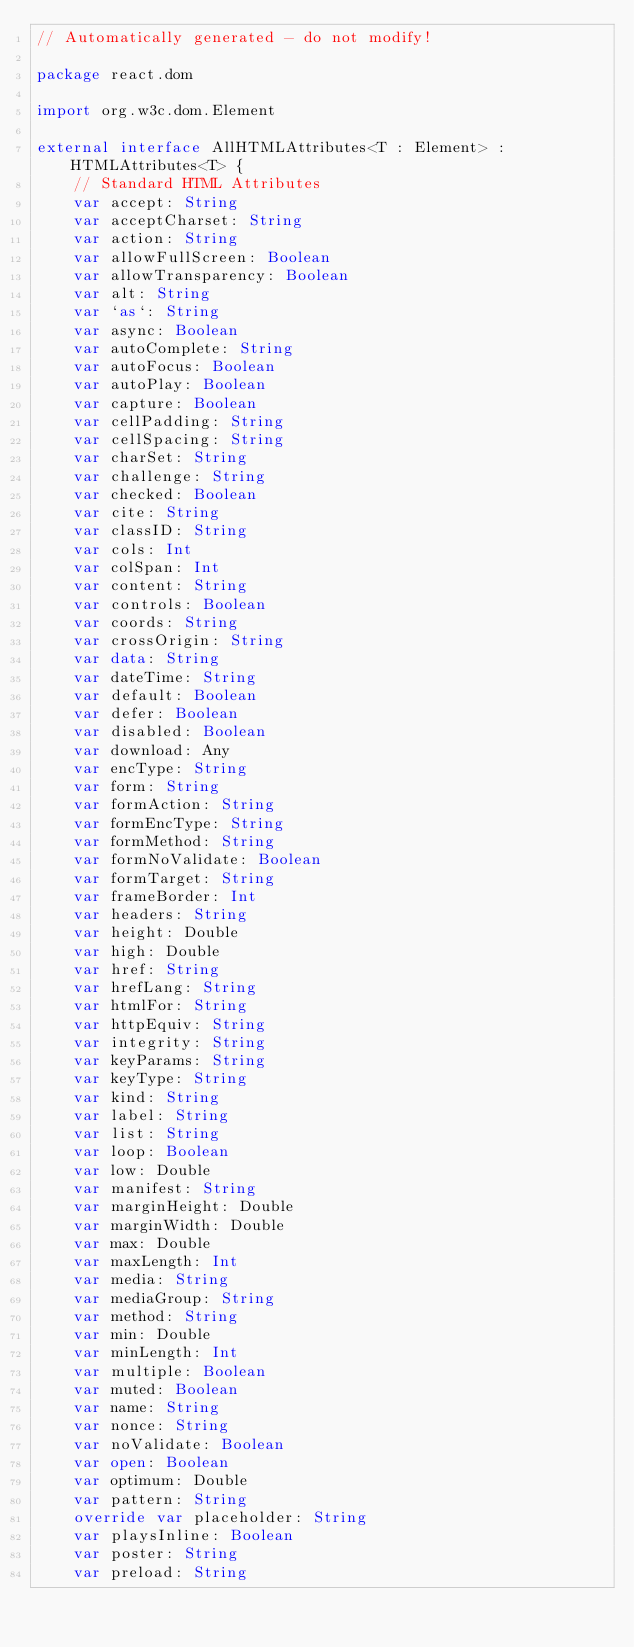Convert code to text. <code><loc_0><loc_0><loc_500><loc_500><_Kotlin_>// Automatically generated - do not modify!

package react.dom

import org.w3c.dom.Element

external interface AllHTMLAttributes<T : Element> : HTMLAttributes<T> {
    // Standard HTML Attributes
    var accept: String
    var acceptCharset: String
    var action: String
    var allowFullScreen: Boolean
    var allowTransparency: Boolean
    var alt: String
    var `as`: String
    var async: Boolean
    var autoComplete: String
    var autoFocus: Boolean
    var autoPlay: Boolean
    var capture: Boolean
    var cellPadding: String
    var cellSpacing: String
    var charSet: String
    var challenge: String
    var checked: Boolean
    var cite: String
    var classID: String
    var cols: Int
    var colSpan: Int
    var content: String
    var controls: Boolean
    var coords: String
    var crossOrigin: String
    var data: String
    var dateTime: String
    var default: Boolean
    var defer: Boolean
    var disabled: Boolean
    var download: Any
    var encType: String
    var form: String
    var formAction: String
    var formEncType: String
    var formMethod: String
    var formNoValidate: Boolean
    var formTarget: String
    var frameBorder: Int
    var headers: String
    var height: Double
    var high: Double
    var href: String
    var hrefLang: String
    var htmlFor: String
    var httpEquiv: String
    var integrity: String
    var keyParams: String
    var keyType: String
    var kind: String
    var label: String
    var list: String
    var loop: Boolean
    var low: Double
    var manifest: String
    var marginHeight: Double
    var marginWidth: Double
    var max: Double
    var maxLength: Int
    var media: String
    var mediaGroup: String
    var method: String
    var min: Double
    var minLength: Int
    var multiple: Boolean
    var muted: Boolean
    var name: String
    var nonce: String
    var noValidate: Boolean
    var open: Boolean
    var optimum: Double
    var pattern: String
    override var placeholder: String
    var playsInline: Boolean
    var poster: String
    var preload: String</code> 